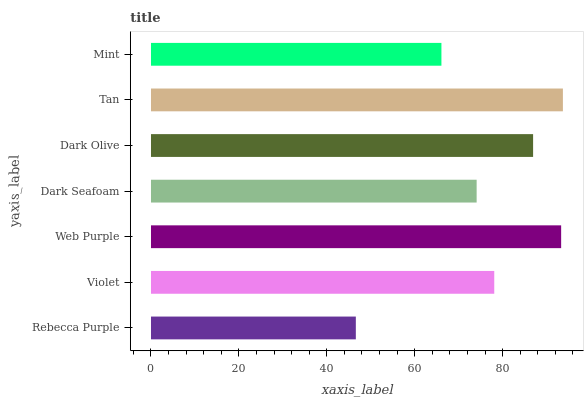Is Rebecca Purple the minimum?
Answer yes or no. Yes. Is Tan the maximum?
Answer yes or no. Yes. Is Violet the minimum?
Answer yes or no. No. Is Violet the maximum?
Answer yes or no. No. Is Violet greater than Rebecca Purple?
Answer yes or no. Yes. Is Rebecca Purple less than Violet?
Answer yes or no. Yes. Is Rebecca Purple greater than Violet?
Answer yes or no. No. Is Violet less than Rebecca Purple?
Answer yes or no. No. Is Violet the high median?
Answer yes or no. Yes. Is Violet the low median?
Answer yes or no. Yes. Is Web Purple the high median?
Answer yes or no. No. Is Web Purple the low median?
Answer yes or no. No. 